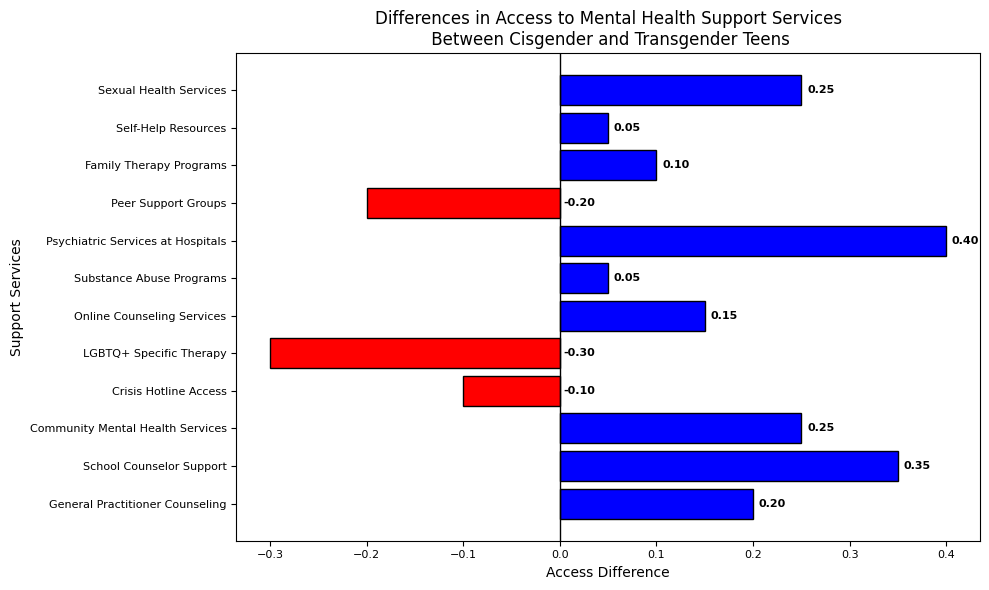Which service has the largest positive access difference? The service with the largest bar extending to the right (positive value) represents the largest positive access difference. The "Psychiatric Services at Hospitals" bar is the longest in that direction.
Answer: Psychiatric Services at Hospitals Which service has the largest negative access difference? The service with the largest bar extending to the left (negative value) represents the largest negative access difference. The "LGBTQ+ Specific Therapy" bar is the longest in that direction.
Answer: LGBTQ+ Specific Therapy How many services show greater access for cisgender teens compared to transgender teens? Services with positive access differences are colored blue. By counting the blue bars, there are 9 services with greater access for cisgender teens.
Answer: 9 What is the combined access difference for "School Counselor Support" and "Community Mental Health Services"? Sum the access differences for these services (0.35 + 0.25).
Answer: 0.60 Which has a smaller access difference: "Online Counseling Services" or "General Practitioner Counseling"? Compare the lengths of the bars for these two services. "Online Counseling Services" has a smaller access difference (0.15) compared to "General Practitioner Counseling" (0.20).
Answer: Online Counseling Services Is "Crisis Hotline Access" more accessible for cisgender or transgender teens? The "Crisis Hotline Access" bar is red and extends to the left (negative value), indicating it is more accessible for transgender teens.
Answer: Transgender teens Which services have an access difference of 0.25? Identify the bars with exactly 0.25 length. "Community Mental Health Services" and "Sexual Health Services" both have an access difference of 0.25.
Answer: Community Mental Health Services, Sexual Health Services What's the total access difference for services with positive access for cisgender teens? Sum all positive values: 0.20 + 0.35 + 0.25 + 0.15 + 0.05 + 0.40 + 0.10 + 0.05 + 0.25 = 1.80
Answer: 1.80 What is the difference in access between "Peer Support Groups" and "Family Therapy Programs"? Subtract the access difference of "Peer Support Groups" from "Family Therapy Programs" (0.10 - (-0.20) = 0.30 + 0.10).
Answer: 0.30 How many services show less access for transgender teens compared to cisgender teens? Services with negative access differences are colored red. By counting the red bars, there are 3 services with less access for transgender teens.
Answer: 3 